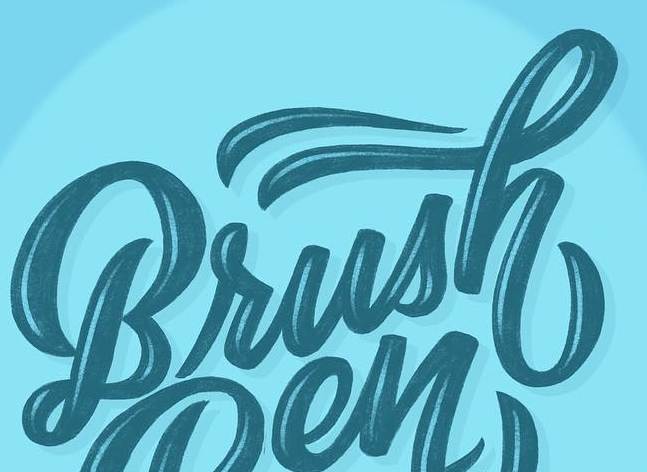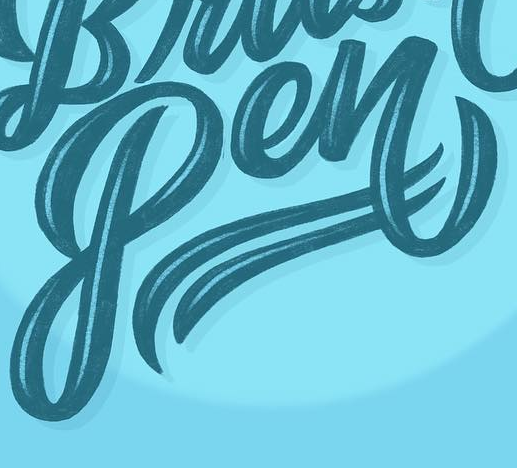Read the text from these images in sequence, separated by a semicolon. Brush; Pen 